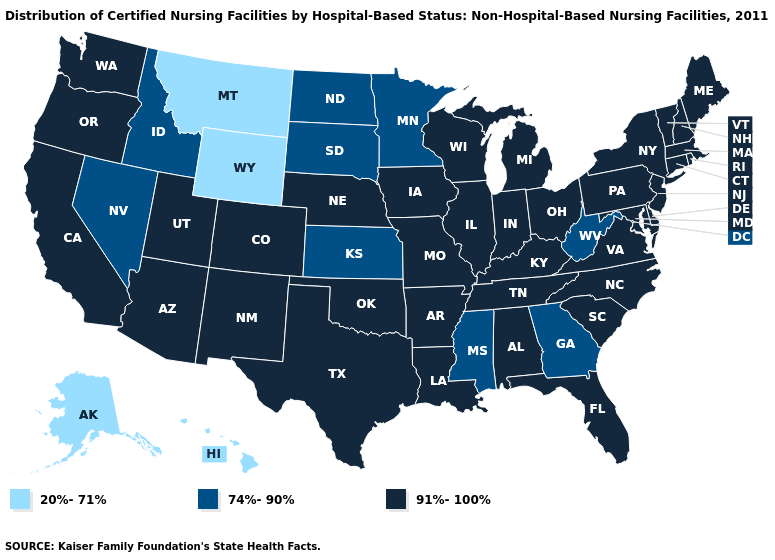Among the states that border Washington , which have the lowest value?
Quick response, please. Idaho. What is the value of Oregon?
Answer briefly. 91%-100%. What is the value of Louisiana?
Short answer required. 91%-100%. What is the highest value in states that border New York?
Quick response, please. 91%-100%. What is the value of Mississippi?
Keep it brief. 74%-90%. Name the states that have a value in the range 91%-100%?
Be succinct. Alabama, Arizona, Arkansas, California, Colorado, Connecticut, Delaware, Florida, Illinois, Indiana, Iowa, Kentucky, Louisiana, Maine, Maryland, Massachusetts, Michigan, Missouri, Nebraska, New Hampshire, New Jersey, New Mexico, New York, North Carolina, Ohio, Oklahoma, Oregon, Pennsylvania, Rhode Island, South Carolina, Tennessee, Texas, Utah, Vermont, Virginia, Washington, Wisconsin. What is the value of Colorado?
Write a very short answer. 91%-100%. What is the value of Indiana?
Give a very brief answer. 91%-100%. What is the lowest value in the USA?
Give a very brief answer. 20%-71%. Name the states that have a value in the range 91%-100%?
Be succinct. Alabama, Arizona, Arkansas, California, Colorado, Connecticut, Delaware, Florida, Illinois, Indiana, Iowa, Kentucky, Louisiana, Maine, Maryland, Massachusetts, Michigan, Missouri, Nebraska, New Hampshire, New Jersey, New Mexico, New York, North Carolina, Ohio, Oklahoma, Oregon, Pennsylvania, Rhode Island, South Carolina, Tennessee, Texas, Utah, Vermont, Virginia, Washington, Wisconsin. Name the states that have a value in the range 74%-90%?
Short answer required. Georgia, Idaho, Kansas, Minnesota, Mississippi, Nevada, North Dakota, South Dakota, West Virginia. What is the value of Oregon?
Be succinct. 91%-100%. What is the value of Florida?
Give a very brief answer. 91%-100%. Does the first symbol in the legend represent the smallest category?
Quick response, please. Yes. Name the states that have a value in the range 20%-71%?
Answer briefly. Alaska, Hawaii, Montana, Wyoming. 